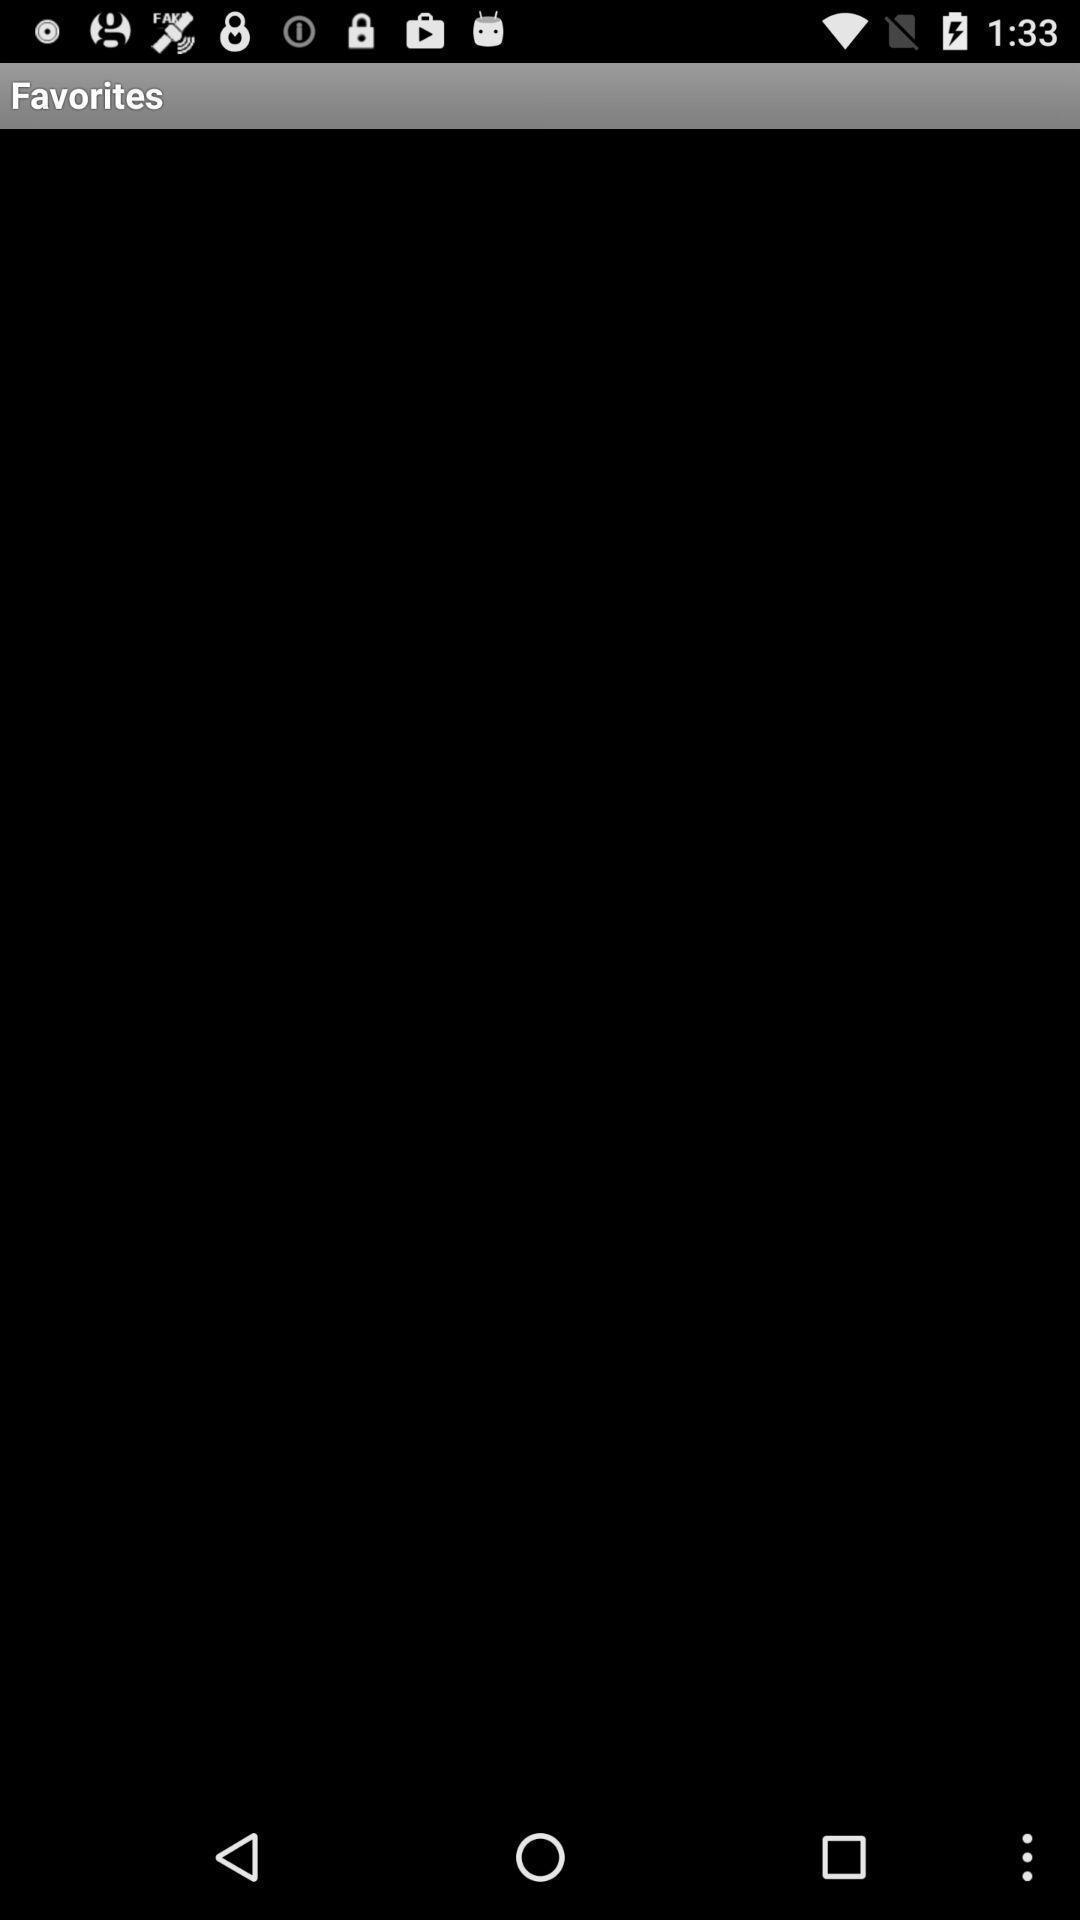Describe the content in this image. Page showing favorites. 